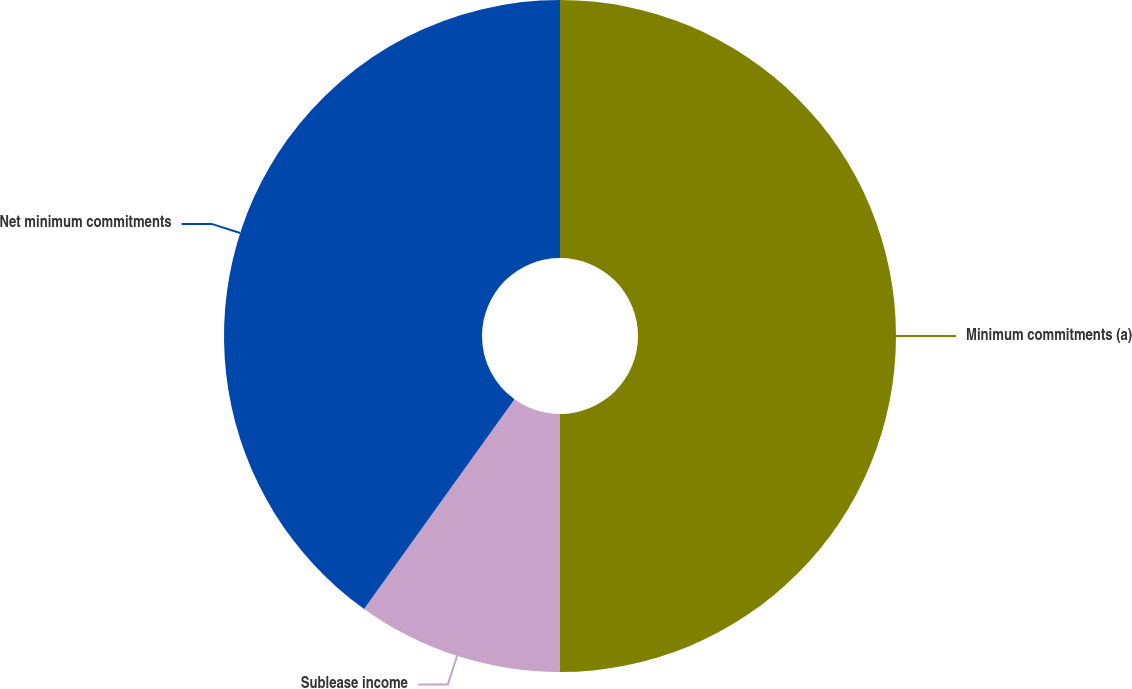<chart> <loc_0><loc_0><loc_500><loc_500><pie_chart><fcel>Minimum commitments (a)<fcel>Sublease income<fcel>Net minimum commitments<nl><fcel>50.0%<fcel>9.91%<fcel>40.09%<nl></chart> 